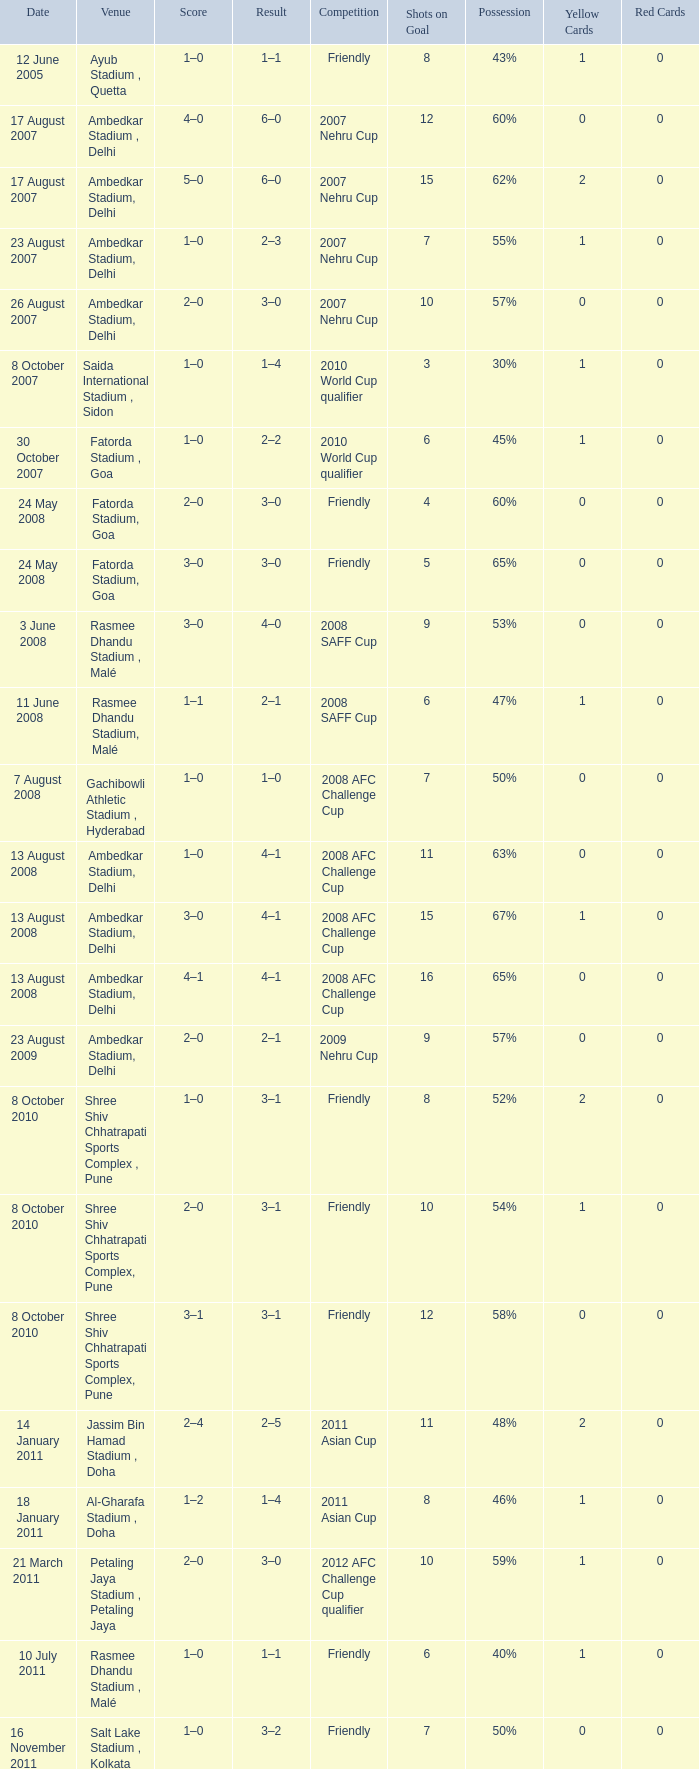Tell me the score on 22 august 2012 1–0. 